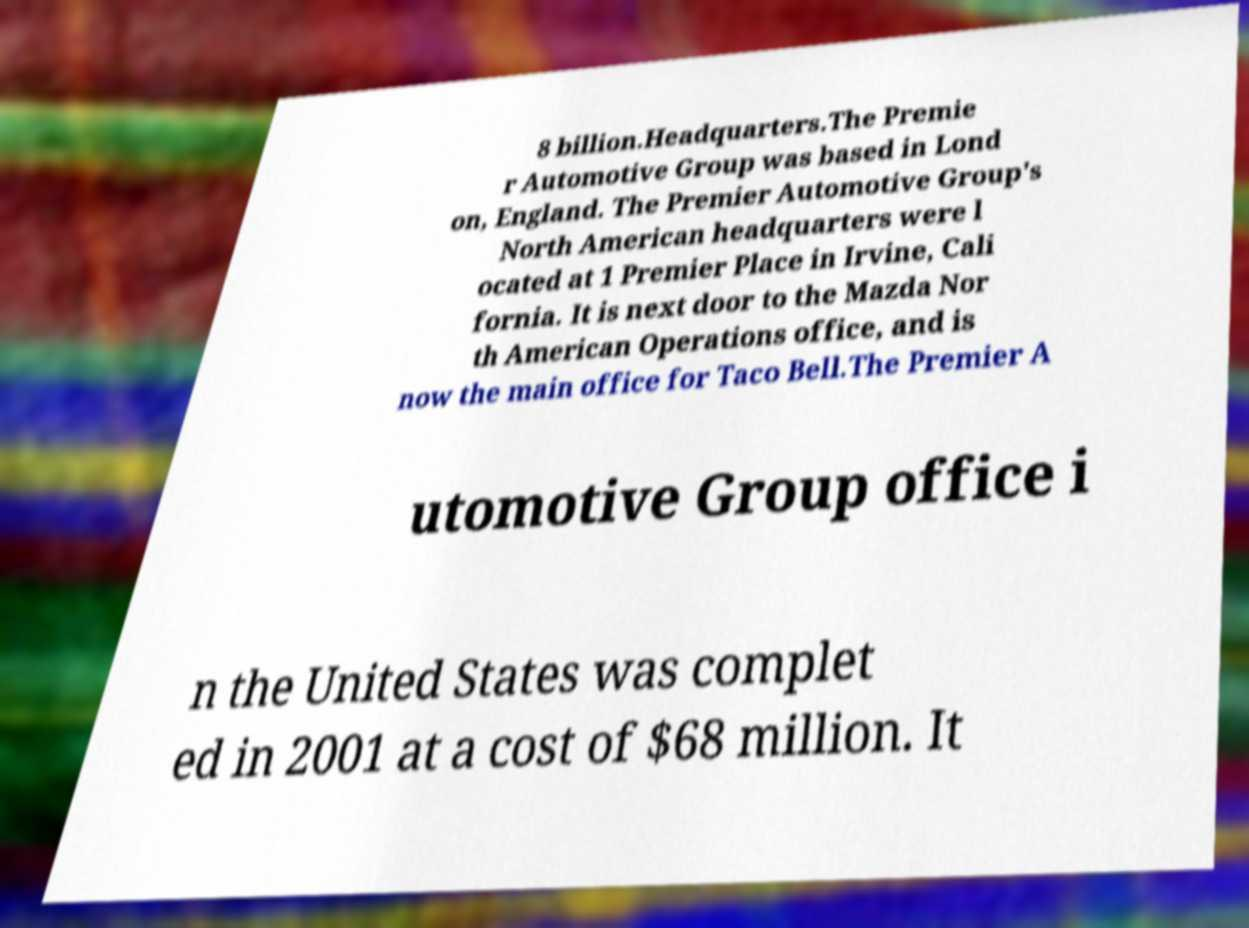Could you extract and type out the text from this image? 8 billion.Headquarters.The Premie r Automotive Group was based in Lond on, England. The Premier Automotive Group's North American headquarters were l ocated at 1 Premier Place in Irvine, Cali fornia. It is next door to the Mazda Nor th American Operations office, and is now the main office for Taco Bell.The Premier A utomotive Group office i n the United States was complet ed in 2001 at a cost of $68 million. It 